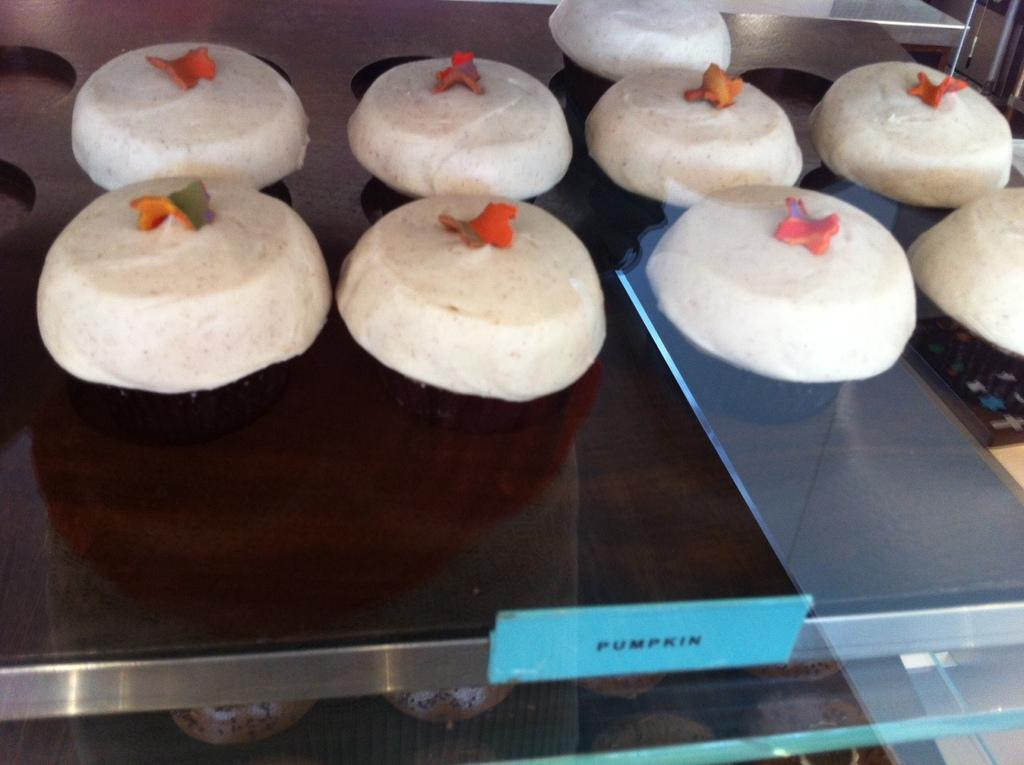What is the main subject of the image? The main subject of the image is food. What can be observed about the surface the food is on? The surface the food is on is brown in color. Is there any text visible in the image? Yes, there is text written in the front of the image. How does the food attack the nerve in the image? There is no mention of an attack or nerve in the image; it simply features food on a brown surface with text. 